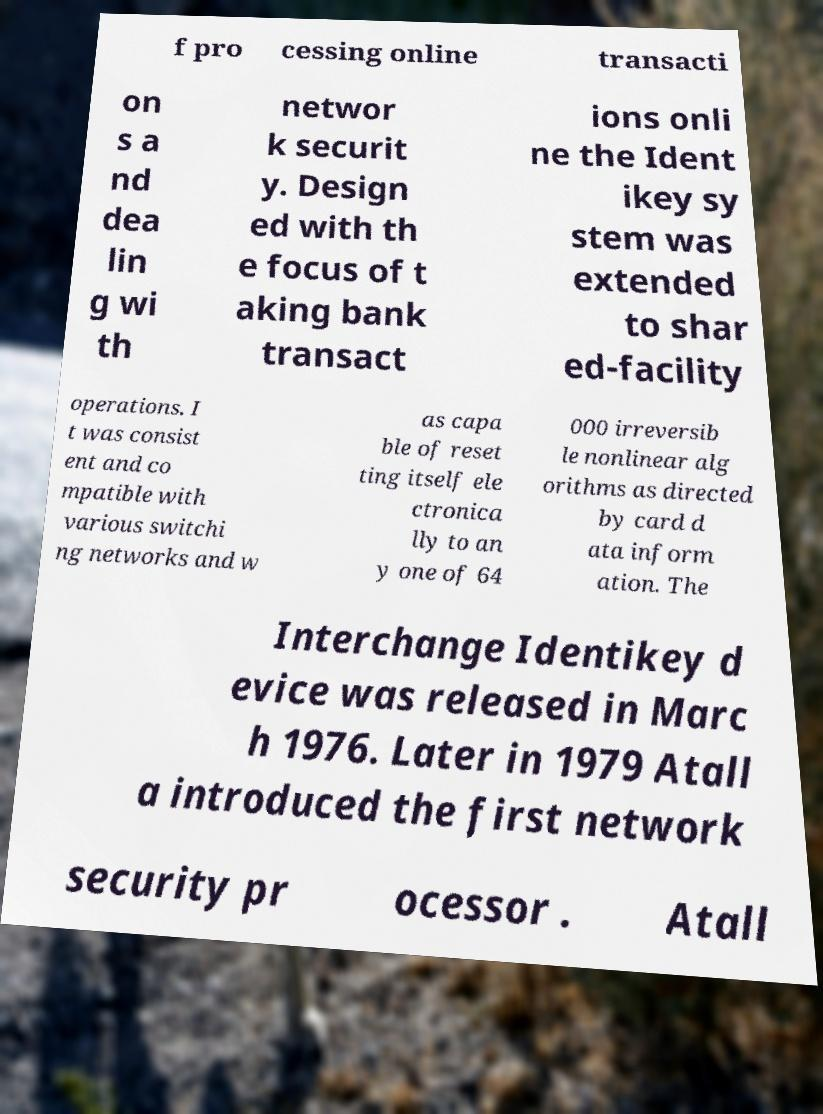Can you accurately transcribe the text from the provided image for me? f pro cessing online transacti on s a nd dea lin g wi th networ k securit y. Design ed with th e focus of t aking bank transact ions onli ne the Ident ikey sy stem was extended to shar ed-facility operations. I t was consist ent and co mpatible with various switchi ng networks and w as capa ble of reset ting itself ele ctronica lly to an y one of 64 000 irreversib le nonlinear alg orithms as directed by card d ata inform ation. The Interchange Identikey d evice was released in Marc h 1976. Later in 1979 Atall a introduced the first network security pr ocessor . Atall 